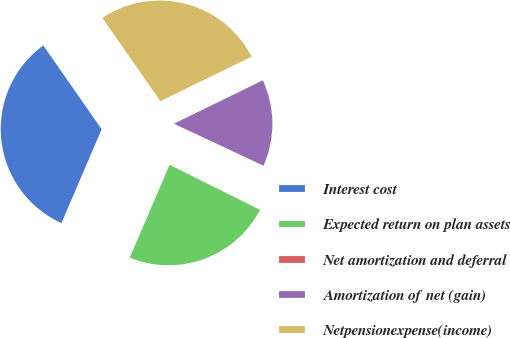<chart> <loc_0><loc_0><loc_500><loc_500><pie_chart><fcel>Interest cost<fcel>Expected return on plan assets<fcel>Net amortization and deferral<fcel>Amortization of net (gain)<fcel>Netpensionexpense(income)<nl><fcel>33.87%<fcel>24.1%<fcel>0.36%<fcel>14.21%<fcel>27.45%<nl></chart> 